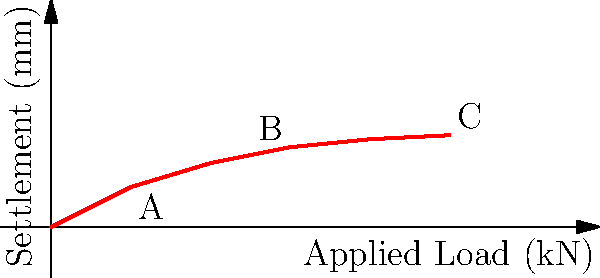As a nutritionist specializing in energy-boosting diets, you're consulting on a project to build a health food store. The civil engineer shows you this load-settlement curve for the building's foundation. If the allowable settlement is 1.0 mm, what is the maximum load the foundation can support before exceeding this limit? To solve this problem, we need to analyze the load-settlement curve:

1. The allowable settlement is given as 1.0 mm.
2. We need to find the corresponding load on the x-axis for this settlement value on the y-axis.
3. Examining the curve, we can see that the 1.0 mm settlement point is labeled as point B.
4. Point B corresponds to a load of 3 kN on the x-axis.

Therefore, the maximum load the foundation can support before exceeding the allowable settlement of 1.0 mm is 3 kN.

This information is crucial for ensuring the structural integrity of the health food store, which aligns with your goal of promoting well-balanced, energy-boosting diets through proper nutrition and a safe shopping environment.
Answer: 3 kN 